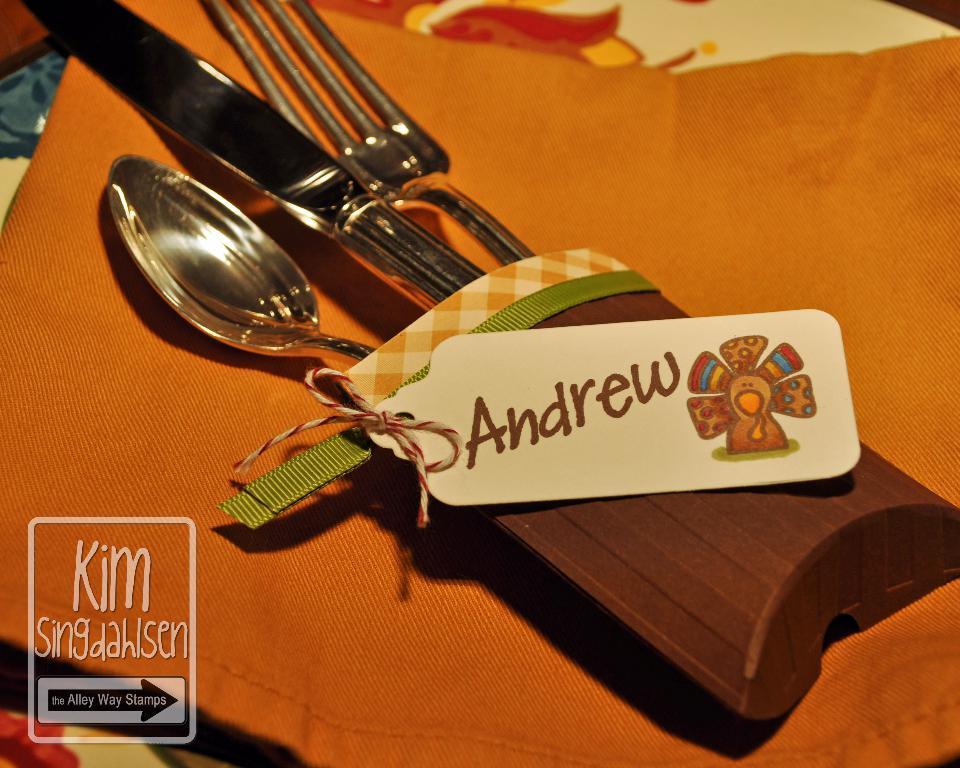In one or two sentences, can you explain what this image depicts? In this image I can see a spoon, fork and knife on the cloth and the cloth is in orange color. 